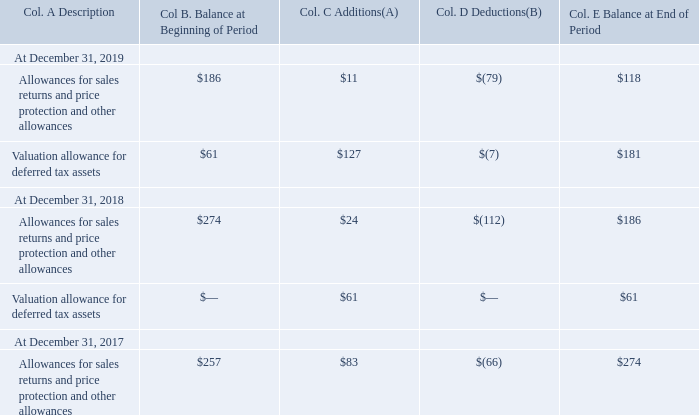VALUATION AND QUALIFYING ACCOUNTS
(Amounts in millions)
(A) Includes increases and reversals of allowances for sales returns, price protection, and valuation allowance for deferred tax assets due to normal reserving terms.
(B) Includes actual write-offs and utilization of allowances for sales returns, price protection, and releases of income tax valuation allowances and foreign currency translation and other adjustments.
What was the Valuation allowance for deferred tax assets at the beginning of the period of 2019?
Answer scale should be: million. $61. What was the Valuation allowance for deferred tax assets at the end of the period of 2019?
Answer scale should be: million. $181. What was the Allowances for sales returns and price protection and other allowances at the beginning of the period in 2018?
Answer scale should be: million. $274. What was the change in Valuation allowance for deferred tax assets between 2018 and 2019?
Answer scale should be: million. $181-$61
Answer: 120. What was the sum of Col. C Additions in 2018?
Answer scale should be: million. $24+$61
Answer: 85. What was the sum of balances at the end of the period in 2019?
Answer scale should be: million. $118+$181
Answer: 299. 